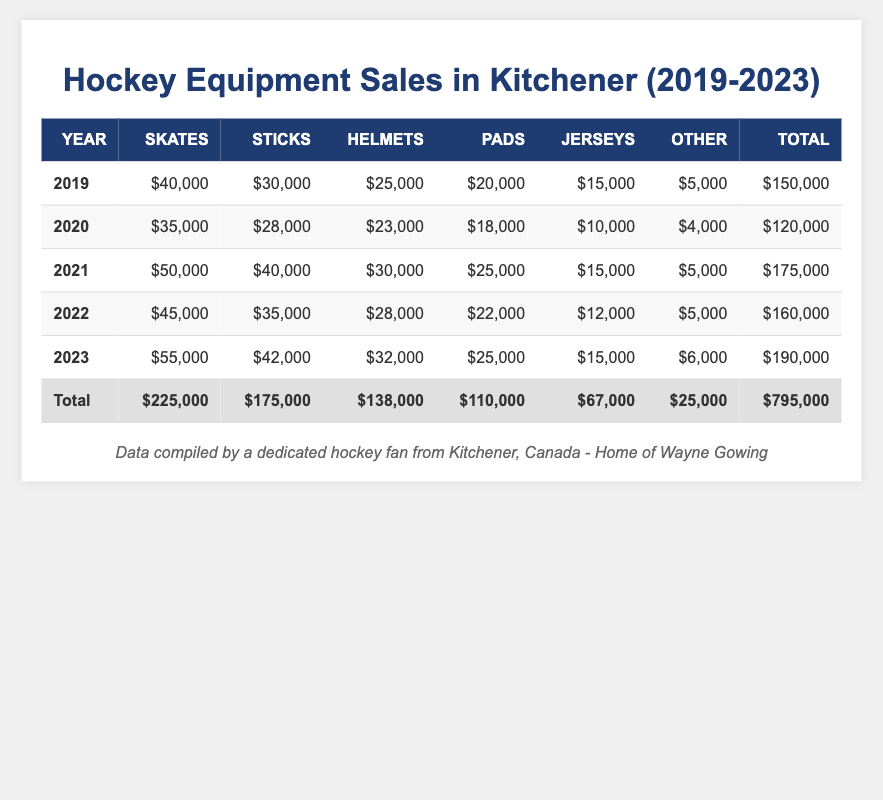What was the total sales amount in Kitchener for hockey equipment in 2021? The total sales amount for 2021 is listed under the "Total" column for that year, which is $175,000.
Answer: $175,000 Which year had the highest sales of skates? The year with the highest sales of skates is 2023, with sales of $55,000.
Answer: 2023 In which year did equipment sales first exceed $150,000? Sales first exceeded $150,000 in 2021, as the total for that year is $175,000 which is the first year above $150,000.
Answer: 2021 What is the total sales for sticks over the five years? Adding up the sticks sales amounts from each year gives us (30,000 + 28,000 + 40,000 + 35,000 + 42,000) = 175,000.
Answer: $175,000 True or False: The total sales in 2020 were lower than in 2019. The total sales for 2019 is $150,000 and for 2020 is $120,000, which means that 2020 sales were indeed lower.
Answer: True What was the overall increase in total sales from 2020 to 2023? To find the increase, subtract the total sales of 2020 from 2023: $190,000 - $120,000 = $70,000.
Answer: $70,000 Which year had the lowest sales for helmets and what was the amount? The lowest sales for helmets occurred in 2020 with an amount of $23,000.
Answer: 2020, $23,000 If we average the total sales across all five years, what is the average? The average is calculated by summing total sales for the years (150,000 + 120,000 + 175,000 + 160,000 + 190,000) = 795,000 and dividing by 5 gives an average of 795,000 / 5 = $159,000.
Answer: $159,000 What percentage of the total sales in 2022 came from the sales of pads? In 2022, the sales from pads was $22,000. The total sales being $160,000. The percentage is calculated as ($22,000 / $160,000) * 100 = 13.75%.
Answer: 13.75% What was the change in total sales from 2019 to 2023? The change is found by subtracting 2019's total sales from 2023's: $190,000 - $150,000 = $40,000 increase.
Answer: $40,000 increase 